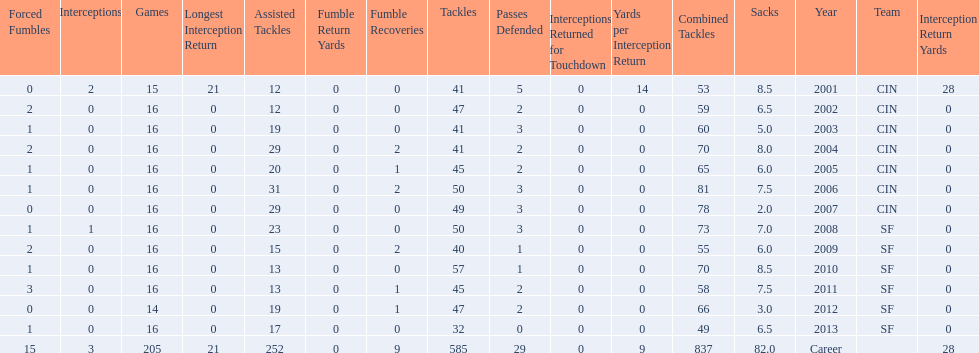What is the total number of sacks smith has made? 82.0. 